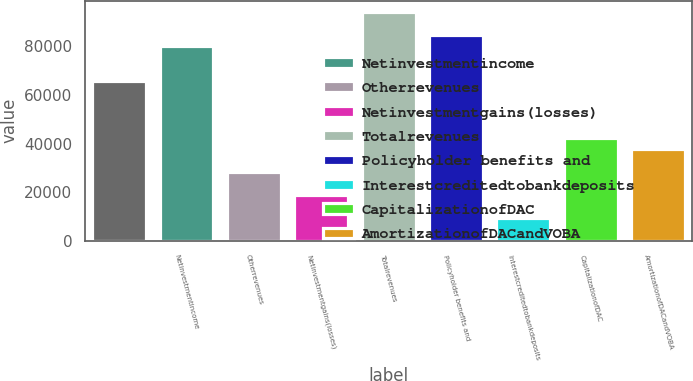Convert chart to OTSL. <chart><loc_0><loc_0><loc_500><loc_500><bar_chart><ecel><fcel>Netinvestmentincome<fcel>Otherrevenues<fcel>Netinvestmentgains(losses)<fcel>Totalrevenues<fcel>Policyholder benefits and<fcel>Interestcreditedtobankdeposits<fcel>CapitalizationofDAC<fcel>AmortizationofDACandVOBA<nl><fcel>65958<fcel>80062.5<fcel>28346<fcel>18943<fcel>94167<fcel>84764<fcel>9540<fcel>42450.5<fcel>37749<nl></chart> 